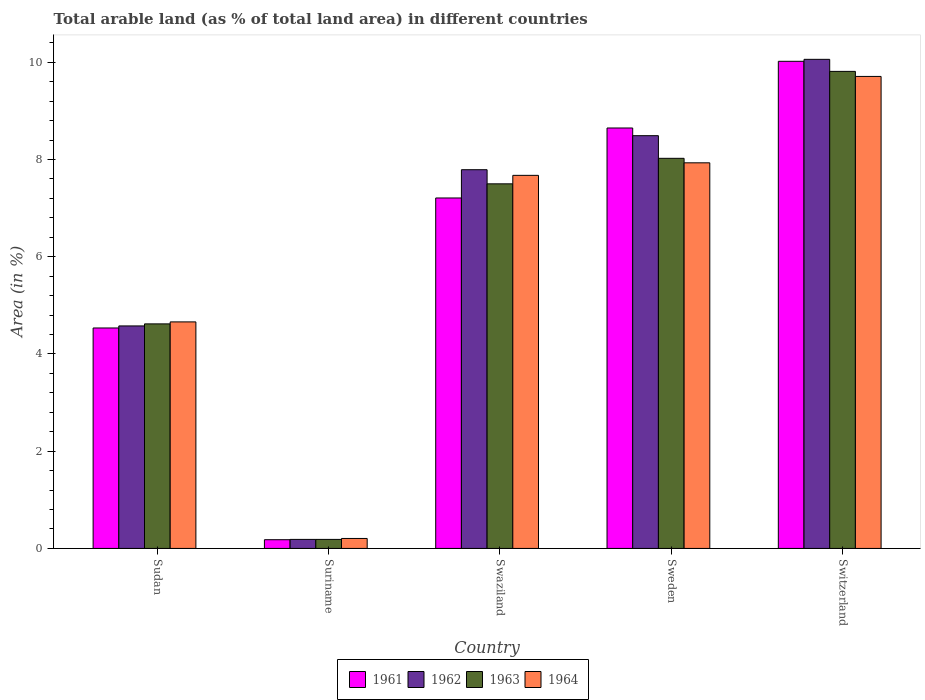How many different coloured bars are there?
Provide a short and direct response. 4. How many groups of bars are there?
Your response must be concise. 5. Are the number of bars per tick equal to the number of legend labels?
Your answer should be compact. Yes. Are the number of bars on each tick of the X-axis equal?
Keep it short and to the point. Yes. How many bars are there on the 1st tick from the left?
Ensure brevity in your answer.  4. How many bars are there on the 5th tick from the right?
Provide a succinct answer. 4. What is the label of the 5th group of bars from the left?
Offer a very short reply. Switzerland. In how many cases, is the number of bars for a given country not equal to the number of legend labels?
Keep it short and to the point. 0. What is the percentage of arable land in 1963 in Sudan?
Offer a terse response. 4.62. Across all countries, what is the maximum percentage of arable land in 1963?
Your response must be concise. 9.81. Across all countries, what is the minimum percentage of arable land in 1964?
Give a very brief answer. 0.21. In which country was the percentage of arable land in 1961 maximum?
Offer a very short reply. Switzerland. In which country was the percentage of arable land in 1964 minimum?
Your answer should be compact. Suriname. What is the total percentage of arable land in 1964 in the graph?
Make the answer very short. 30.18. What is the difference between the percentage of arable land in 1962 in Sudan and that in Suriname?
Offer a terse response. 4.39. What is the difference between the percentage of arable land in 1961 in Sudan and the percentage of arable land in 1963 in Swaziland?
Your response must be concise. -2.97. What is the average percentage of arable land in 1961 per country?
Provide a succinct answer. 6.12. What is the difference between the percentage of arable land of/in 1962 and percentage of arable land of/in 1963 in Sudan?
Provide a succinct answer. -0.04. In how many countries, is the percentage of arable land in 1963 greater than 1.2000000000000002 %?
Your answer should be compact. 4. What is the ratio of the percentage of arable land in 1961 in Sudan to that in Suriname?
Give a very brief answer. 25.27. What is the difference between the highest and the second highest percentage of arable land in 1964?
Provide a short and direct response. 2.04. What is the difference between the highest and the lowest percentage of arable land in 1963?
Provide a short and direct response. 9.63. Is it the case that in every country, the sum of the percentage of arable land in 1964 and percentage of arable land in 1962 is greater than the sum of percentage of arable land in 1961 and percentage of arable land in 1963?
Offer a terse response. No. What does the 3rd bar from the left in Sudan represents?
Offer a terse response. 1963. Is it the case that in every country, the sum of the percentage of arable land in 1961 and percentage of arable land in 1963 is greater than the percentage of arable land in 1962?
Your answer should be very brief. Yes. How many bars are there?
Keep it short and to the point. 20. How many countries are there in the graph?
Your answer should be very brief. 5. Does the graph contain grids?
Offer a terse response. No. How many legend labels are there?
Offer a terse response. 4. How are the legend labels stacked?
Offer a terse response. Horizontal. What is the title of the graph?
Make the answer very short. Total arable land (as % of total land area) in different countries. What is the label or title of the X-axis?
Offer a terse response. Country. What is the label or title of the Y-axis?
Provide a short and direct response. Area (in %). What is the Area (in %) of 1961 in Sudan?
Your answer should be compact. 4.53. What is the Area (in %) of 1962 in Sudan?
Keep it short and to the point. 4.58. What is the Area (in %) of 1963 in Sudan?
Provide a short and direct response. 4.62. What is the Area (in %) in 1964 in Sudan?
Ensure brevity in your answer.  4.66. What is the Area (in %) in 1961 in Suriname?
Your response must be concise. 0.18. What is the Area (in %) of 1962 in Suriname?
Give a very brief answer. 0.19. What is the Area (in %) of 1963 in Suriname?
Provide a succinct answer. 0.19. What is the Area (in %) of 1964 in Suriname?
Your answer should be compact. 0.21. What is the Area (in %) in 1961 in Swaziland?
Offer a very short reply. 7.21. What is the Area (in %) in 1962 in Swaziland?
Provide a short and direct response. 7.79. What is the Area (in %) of 1963 in Swaziland?
Your response must be concise. 7.5. What is the Area (in %) in 1964 in Swaziland?
Provide a succinct answer. 7.67. What is the Area (in %) of 1961 in Sweden?
Offer a very short reply. 8.65. What is the Area (in %) of 1962 in Sweden?
Give a very brief answer. 8.49. What is the Area (in %) of 1963 in Sweden?
Make the answer very short. 8.03. What is the Area (in %) of 1964 in Sweden?
Offer a very short reply. 7.93. What is the Area (in %) of 1961 in Switzerland?
Your answer should be compact. 10.02. What is the Area (in %) of 1962 in Switzerland?
Your answer should be very brief. 10.06. What is the Area (in %) of 1963 in Switzerland?
Your response must be concise. 9.81. What is the Area (in %) of 1964 in Switzerland?
Offer a very short reply. 9.71. Across all countries, what is the maximum Area (in %) of 1961?
Provide a short and direct response. 10.02. Across all countries, what is the maximum Area (in %) of 1962?
Ensure brevity in your answer.  10.06. Across all countries, what is the maximum Area (in %) of 1963?
Provide a succinct answer. 9.81. Across all countries, what is the maximum Area (in %) in 1964?
Your response must be concise. 9.71. Across all countries, what is the minimum Area (in %) of 1961?
Your answer should be compact. 0.18. Across all countries, what is the minimum Area (in %) in 1962?
Keep it short and to the point. 0.19. Across all countries, what is the minimum Area (in %) in 1963?
Make the answer very short. 0.19. Across all countries, what is the minimum Area (in %) of 1964?
Offer a very short reply. 0.21. What is the total Area (in %) of 1961 in the graph?
Your answer should be very brief. 30.59. What is the total Area (in %) in 1962 in the graph?
Make the answer very short. 31.11. What is the total Area (in %) of 1963 in the graph?
Offer a very short reply. 30.14. What is the total Area (in %) in 1964 in the graph?
Your answer should be very brief. 30.18. What is the difference between the Area (in %) in 1961 in Sudan and that in Suriname?
Your response must be concise. 4.36. What is the difference between the Area (in %) of 1962 in Sudan and that in Suriname?
Your response must be concise. 4.39. What is the difference between the Area (in %) of 1963 in Sudan and that in Suriname?
Provide a short and direct response. 4.43. What is the difference between the Area (in %) of 1964 in Sudan and that in Suriname?
Offer a very short reply. 4.45. What is the difference between the Area (in %) of 1961 in Sudan and that in Swaziland?
Make the answer very short. -2.67. What is the difference between the Area (in %) in 1962 in Sudan and that in Swaziland?
Your answer should be very brief. -3.21. What is the difference between the Area (in %) of 1963 in Sudan and that in Swaziland?
Your response must be concise. -2.88. What is the difference between the Area (in %) of 1964 in Sudan and that in Swaziland?
Offer a very short reply. -3.01. What is the difference between the Area (in %) of 1961 in Sudan and that in Sweden?
Your response must be concise. -4.11. What is the difference between the Area (in %) in 1962 in Sudan and that in Sweden?
Your answer should be very brief. -3.91. What is the difference between the Area (in %) in 1963 in Sudan and that in Sweden?
Your answer should be very brief. -3.41. What is the difference between the Area (in %) in 1964 in Sudan and that in Sweden?
Keep it short and to the point. -3.27. What is the difference between the Area (in %) of 1961 in Sudan and that in Switzerland?
Give a very brief answer. -5.49. What is the difference between the Area (in %) in 1962 in Sudan and that in Switzerland?
Give a very brief answer. -5.48. What is the difference between the Area (in %) of 1963 in Sudan and that in Switzerland?
Make the answer very short. -5.19. What is the difference between the Area (in %) in 1964 in Sudan and that in Switzerland?
Provide a short and direct response. -5.05. What is the difference between the Area (in %) of 1961 in Suriname and that in Swaziland?
Keep it short and to the point. -7.03. What is the difference between the Area (in %) of 1962 in Suriname and that in Swaziland?
Provide a short and direct response. -7.6. What is the difference between the Area (in %) in 1963 in Suriname and that in Swaziland?
Offer a terse response. -7.31. What is the difference between the Area (in %) in 1964 in Suriname and that in Swaziland?
Offer a terse response. -7.47. What is the difference between the Area (in %) of 1961 in Suriname and that in Sweden?
Offer a very short reply. -8.47. What is the difference between the Area (in %) in 1962 in Suriname and that in Sweden?
Keep it short and to the point. -8.3. What is the difference between the Area (in %) in 1963 in Suriname and that in Sweden?
Offer a very short reply. -7.84. What is the difference between the Area (in %) in 1964 in Suriname and that in Sweden?
Offer a terse response. -7.73. What is the difference between the Area (in %) of 1961 in Suriname and that in Switzerland?
Offer a terse response. -9.84. What is the difference between the Area (in %) of 1962 in Suriname and that in Switzerland?
Give a very brief answer. -9.88. What is the difference between the Area (in %) in 1963 in Suriname and that in Switzerland?
Your answer should be very brief. -9.63. What is the difference between the Area (in %) of 1964 in Suriname and that in Switzerland?
Your response must be concise. -9.5. What is the difference between the Area (in %) in 1961 in Swaziland and that in Sweden?
Your answer should be very brief. -1.44. What is the difference between the Area (in %) of 1962 in Swaziland and that in Sweden?
Your answer should be very brief. -0.7. What is the difference between the Area (in %) of 1963 in Swaziland and that in Sweden?
Give a very brief answer. -0.53. What is the difference between the Area (in %) in 1964 in Swaziland and that in Sweden?
Your response must be concise. -0.26. What is the difference between the Area (in %) of 1961 in Swaziland and that in Switzerland?
Ensure brevity in your answer.  -2.81. What is the difference between the Area (in %) in 1962 in Swaziland and that in Switzerland?
Your response must be concise. -2.27. What is the difference between the Area (in %) of 1963 in Swaziland and that in Switzerland?
Offer a very short reply. -2.31. What is the difference between the Area (in %) in 1964 in Swaziland and that in Switzerland?
Make the answer very short. -2.04. What is the difference between the Area (in %) of 1961 in Sweden and that in Switzerland?
Make the answer very short. -1.37. What is the difference between the Area (in %) of 1962 in Sweden and that in Switzerland?
Offer a very short reply. -1.57. What is the difference between the Area (in %) in 1963 in Sweden and that in Switzerland?
Make the answer very short. -1.79. What is the difference between the Area (in %) in 1964 in Sweden and that in Switzerland?
Make the answer very short. -1.78. What is the difference between the Area (in %) in 1961 in Sudan and the Area (in %) in 1962 in Suriname?
Provide a succinct answer. 4.35. What is the difference between the Area (in %) in 1961 in Sudan and the Area (in %) in 1963 in Suriname?
Offer a very short reply. 4.35. What is the difference between the Area (in %) of 1961 in Sudan and the Area (in %) of 1964 in Suriname?
Provide a succinct answer. 4.33. What is the difference between the Area (in %) in 1962 in Sudan and the Area (in %) in 1963 in Suriname?
Keep it short and to the point. 4.39. What is the difference between the Area (in %) in 1962 in Sudan and the Area (in %) in 1964 in Suriname?
Your answer should be very brief. 4.37. What is the difference between the Area (in %) in 1963 in Sudan and the Area (in %) in 1964 in Suriname?
Ensure brevity in your answer.  4.41. What is the difference between the Area (in %) in 1961 in Sudan and the Area (in %) in 1962 in Swaziland?
Give a very brief answer. -3.26. What is the difference between the Area (in %) of 1961 in Sudan and the Area (in %) of 1963 in Swaziland?
Give a very brief answer. -2.97. What is the difference between the Area (in %) of 1961 in Sudan and the Area (in %) of 1964 in Swaziland?
Make the answer very short. -3.14. What is the difference between the Area (in %) of 1962 in Sudan and the Area (in %) of 1963 in Swaziland?
Your answer should be compact. -2.92. What is the difference between the Area (in %) of 1962 in Sudan and the Area (in %) of 1964 in Swaziland?
Keep it short and to the point. -3.1. What is the difference between the Area (in %) of 1963 in Sudan and the Area (in %) of 1964 in Swaziland?
Your answer should be very brief. -3.06. What is the difference between the Area (in %) of 1961 in Sudan and the Area (in %) of 1962 in Sweden?
Keep it short and to the point. -3.96. What is the difference between the Area (in %) of 1961 in Sudan and the Area (in %) of 1963 in Sweden?
Keep it short and to the point. -3.49. What is the difference between the Area (in %) of 1961 in Sudan and the Area (in %) of 1964 in Sweden?
Give a very brief answer. -3.4. What is the difference between the Area (in %) in 1962 in Sudan and the Area (in %) in 1963 in Sweden?
Make the answer very short. -3.45. What is the difference between the Area (in %) in 1962 in Sudan and the Area (in %) in 1964 in Sweden?
Make the answer very short. -3.36. What is the difference between the Area (in %) of 1963 in Sudan and the Area (in %) of 1964 in Sweden?
Ensure brevity in your answer.  -3.31. What is the difference between the Area (in %) in 1961 in Sudan and the Area (in %) in 1962 in Switzerland?
Your response must be concise. -5.53. What is the difference between the Area (in %) of 1961 in Sudan and the Area (in %) of 1963 in Switzerland?
Provide a succinct answer. -5.28. What is the difference between the Area (in %) of 1961 in Sudan and the Area (in %) of 1964 in Switzerland?
Your response must be concise. -5.17. What is the difference between the Area (in %) of 1962 in Sudan and the Area (in %) of 1963 in Switzerland?
Your response must be concise. -5.24. What is the difference between the Area (in %) in 1962 in Sudan and the Area (in %) in 1964 in Switzerland?
Make the answer very short. -5.13. What is the difference between the Area (in %) in 1963 in Sudan and the Area (in %) in 1964 in Switzerland?
Your answer should be very brief. -5.09. What is the difference between the Area (in %) of 1961 in Suriname and the Area (in %) of 1962 in Swaziland?
Provide a succinct answer. -7.61. What is the difference between the Area (in %) of 1961 in Suriname and the Area (in %) of 1963 in Swaziland?
Keep it short and to the point. -7.32. What is the difference between the Area (in %) of 1961 in Suriname and the Area (in %) of 1964 in Swaziland?
Provide a succinct answer. -7.49. What is the difference between the Area (in %) in 1962 in Suriname and the Area (in %) in 1963 in Swaziland?
Offer a terse response. -7.31. What is the difference between the Area (in %) of 1962 in Suriname and the Area (in %) of 1964 in Swaziland?
Give a very brief answer. -7.49. What is the difference between the Area (in %) of 1963 in Suriname and the Area (in %) of 1964 in Swaziland?
Ensure brevity in your answer.  -7.49. What is the difference between the Area (in %) of 1961 in Suriname and the Area (in %) of 1962 in Sweden?
Offer a very short reply. -8.31. What is the difference between the Area (in %) of 1961 in Suriname and the Area (in %) of 1963 in Sweden?
Give a very brief answer. -7.85. What is the difference between the Area (in %) of 1961 in Suriname and the Area (in %) of 1964 in Sweden?
Offer a terse response. -7.75. What is the difference between the Area (in %) of 1962 in Suriname and the Area (in %) of 1963 in Sweden?
Your answer should be very brief. -7.84. What is the difference between the Area (in %) of 1962 in Suriname and the Area (in %) of 1964 in Sweden?
Your answer should be compact. -7.75. What is the difference between the Area (in %) in 1963 in Suriname and the Area (in %) in 1964 in Sweden?
Give a very brief answer. -7.75. What is the difference between the Area (in %) in 1961 in Suriname and the Area (in %) in 1962 in Switzerland?
Your response must be concise. -9.88. What is the difference between the Area (in %) of 1961 in Suriname and the Area (in %) of 1963 in Switzerland?
Your answer should be very brief. -9.63. What is the difference between the Area (in %) in 1961 in Suriname and the Area (in %) in 1964 in Switzerland?
Keep it short and to the point. -9.53. What is the difference between the Area (in %) of 1962 in Suriname and the Area (in %) of 1963 in Switzerland?
Give a very brief answer. -9.63. What is the difference between the Area (in %) in 1962 in Suriname and the Area (in %) in 1964 in Switzerland?
Ensure brevity in your answer.  -9.52. What is the difference between the Area (in %) of 1963 in Suriname and the Area (in %) of 1964 in Switzerland?
Provide a succinct answer. -9.52. What is the difference between the Area (in %) of 1961 in Swaziland and the Area (in %) of 1962 in Sweden?
Offer a very short reply. -1.28. What is the difference between the Area (in %) of 1961 in Swaziland and the Area (in %) of 1963 in Sweden?
Make the answer very short. -0.82. What is the difference between the Area (in %) of 1961 in Swaziland and the Area (in %) of 1964 in Sweden?
Your response must be concise. -0.72. What is the difference between the Area (in %) of 1962 in Swaziland and the Area (in %) of 1963 in Sweden?
Your answer should be compact. -0.23. What is the difference between the Area (in %) in 1962 in Swaziland and the Area (in %) in 1964 in Sweden?
Make the answer very short. -0.14. What is the difference between the Area (in %) of 1963 in Swaziland and the Area (in %) of 1964 in Sweden?
Give a very brief answer. -0.43. What is the difference between the Area (in %) in 1961 in Swaziland and the Area (in %) in 1962 in Switzerland?
Make the answer very short. -2.85. What is the difference between the Area (in %) of 1961 in Swaziland and the Area (in %) of 1963 in Switzerland?
Keep it short and to the point. -2.6. What is the difference between the Area (in %) of 1961 in Swaziland and the Area (in %) of 1964 in Switzerland?
Ensure brevity in your answer.  -2.5. What is the difference between the Area (in %) in 1962 in Swaziland and the Area (in %) in 1963 in Switzerland?
Keep it short and to the point. -2.02. What is the difference between the Area (in %) in 1962 in Swaziland and the Area (in %) in 1964 in Switzerland?
Your response must be concise. -1.92. What is the difference between the Area (in %) of 1963 in Swaziland and the Area (in %) of 1964 in Switzerland?
Provide a short and direct response. -2.21. What is the difference between the Area (in %) of 1961 in Sweden and the Area (in %) of 1962 in Switzerland?
Keep it short and to the point. -1.41. What is the difference between the Area (in %) in 1961 in Sweden and the Area (in %) in 1963 in Switzerland?
Your answer should be compact. -1.16. What is the difference between the Area (in %) in 1961 in Sweden and the Area (in %) in 1964 in Switzerland?
Ensure brevity in your answer.  -1.06. What is the difference between the Area (in %) of 1962 in Sweden and the Area (in %) of 1963 in Switzerland?
Make the answer very short. -1.32. What is the difference between the Area (in %) of 1962 in Sweden and the Area (in %) of 1964 in Switzerland?
Give a very brief answer. -1.22. What is the difference between the Area (in %) of 1963 in Sweden and the Area (in %) of 1964 in Switzerland?
Provide a short and direct response. -1.68. What is the average Area (in %) of 1961 per country?
Provide a succinct answer. 6.12. What is the average Area (in %) of 1962 per country?
Your answer should be very brief. 6.22. What is the average Area (in %) in 1963 per country?
Your response must be concise. 6.03. What is the average Area (in %) of 1964 per country?
Provide a short and direct response. 6.04. What is the difference between the Area (in %) in 1961 and Area (in %) in 1962 in Sudan?
Offer a terse response. -0.04. What is the difference between the Area (in %) in 1961 and Area (in %) in 1963 in Sudan?
Provide a succinct answer. -0.08. What is the difference between the Area (in %) in 1961 and Area (in %) in 1964 in Sudan?
Provide a short and direct response. -0.12. What is the difference between the Area (in %) of 1962 and Area (in %) of 1963 in Sudan?
Provide a short and direct response. -0.04. What is the difference between the Area (in %) in 1962 and Area (in %) in 1964 in Sudan?
Ensure brevity in your answer.  -0.08. What is the difference between the Area (in %) of 1963 and Area (in %) of 1964 in Sudan?
Make the answer very short. -0.04. What is the difference between the Area (in %) of 1961 and Area (in %) of 1962 in Suriname?
Your response must be concise. -0.01. What is the difference between the Area (in %) in 1961 and Area (in %) in 1963 in Suriname?
Your answer should be compact. -0.01. What is the difference between the Area (in %) of 1961 and Area (in %) of 1964 in Suriname?
Offer a very short reply. -0.03. What is the difference between the Area (in %) of 1962 and Area (in %) of 1964 in Suriname?
Provide a succinct answer. -0.02. What is the difference between the Area (in %) of 1963 and Area (in %) of 1964 in Suriname?
Your answer should be compact. -0.02. What is the difference between the Area (in %) in 1961 and Area (in %) in 1962 in Swaziland?
Your response must be concise. -0.58. What is the difference between the Area (in %) in 1961 and Area (in %) in 1963 in Swaziland?
Make the answer very short. -0.29. What is the difference between the Area (in %) of 1961 and Area (in %) of 1964 in Swaziland?
Offer a very short reply. -0.47. What is the difference between the Area (in %) of 1962 and Area (in %) of 1963 in Swaziland?
Provide a succinct answer. 0.29. What is the difference between the Area (in %) of 1962 and Area (in %) of 1964 in Swaziland?
Give a very brief answer. 0.12. What is the difference between the Area (in %) of 1963 and Area (in %) of 1964 in Swaziland?
Your answer should be very brief. -0.17. What is the difference between the Area (in %) of 1961 and Area (in %) of 1962 in Sweden?
Make the answer very short. 0.16. What is the difference between the Area (in %) in 1961 and Area (in %) in 1963 in Sweden?
Keep it short and to the point. 0.62. What is the difference between the Area (in %) in 1961 and Area (in %) in 1964 in Sweden?
Provide a short and direct response. 0.72. What is the difference between the Area (in %) in 1962 and Area (in %) in 1963 in Sweden?
Your response must be concise. 0.47. What is the difference between the Area (in %) in 1962 and Area (in %) in 1964 in Sweden?
Ensure brevity in your answer.  0.56. What is the difference between the Area (in %) of 1963 and Area (in %) of 1964 in Sweden?
Ensure brevity in your answer.  0.09. What is the difference between the Area (in %) in 1961 and Area (in %) in 1962 in Switzerland?
Your answer should be very brief. -0.04. What is the difference between the Area (in %) of 1961 and Area (in %) of 1963 in Switzerland?
Provide a short and direct response. 0.21. What is the difference between the Area (in %) in 1961 and Area (in %) in 1964 in Switzerland?
Provide a succinct answer. 0.31. What is the difference between the Area (in %) of 1962 and Area (in %) of 1963 in Switzerland?
Your answer should be very brief. 0.25. What is the difference between the Area (in %) in 1962 and Area (in %) in 1964 in Switzerland?
Keep it short and to the point. 0.35. What is the difference between the Area (in %) of 1963 and Area (in %) of 1964 in Switzerland?
Give a very brief answer. 0.1. What is the ratio of the Area (in %) in 1961 in Sudan to that in Suriname?
Give a very brief answer. 25.27. What is the ratio of the Area (in %) in 1962 in Sudan to that in Suriname?
Make the answer very short. 24.62. What is the ratio of the Area (in %) of 1963 in Sudan to that in Suriname?
Make the answer very short. 24.85. What is the ratio of the Area (in %) of 1964 in Sudan to that in Suriname?
Make the answer very short. 22.72. What is the ratio of the Area (in %) of 1961 in Sudan to that in Swaziland?
Offer a very short reply. 0.63. What is the ratio of the Area (in %) of 1962 in Sudan to that in Swaziland?
Provide a short and direct response. 0.59. What is the ratio of the Area (in %) of 1963 in Sudan to that in Swaziland?
Provide a succinct answer. 0.62. What is the ratio of the Area (in %) in 1964 in Sudan to that in Swaziland?
Offer a terse response. 0.61. What is the ratio of the Area (in %) in 1961 in Sudan to that in Sweden?
Your response must be concise. 0.52. What is the ratio of the Area (in %) of 1962 in Sudan to that in Sweden?
Ensure brevity in your answer.  0.54. What is the ratio of the Area (in %) of 1963 in Sudan to that in Sweden?
Offer a terse response. 0.58. What is the ratio of the Area (in %) of 1964 in Sudan to that in Sweden?
Provide a short and direct response. 0.59. What is the ratio of the Area (in %) of 1961 in Sudan to that in Switzerland?
Make the answer very short. 0.45. What is the ratio of the Area (in %) of 1962 in Sudan to that in Switzerland?
Offer a terse response. 0.45. What is the ratio of the Area (in %) in 1963 in Sudan to that in Switzerland?
Your answer should be compact. 0.47. What is the ratio of the Area (in %) in 1964 in Sudan to that in Switzerland?
Offer a very short reply. 0.48. What is the ratio of the Area (in %) of 1961 in Suriname to that in Swaziland?
Your answer should be compact. 0.02. What is the ratio of the Area (in %) of 1962 in Suriname to that in Swaziland?
Make the answer very short. 0.02. What is the ratio of the Area (in %) in 1963 in Suriname to that in Swaziland?
Give a very brief answer. 0.02. What is the ratio of the Area (in %) in 1964 in Suriname to that in Swaziland?
Your response must be concise. 0.03. What is the ratio of the Area (in %) of 1961 in Suriname to that in Sweden?
Ensure brevity in your answer.  0.02. What is the ratio of the Area (in %) of 1962 in Suriname to that in Sweden?
Ensure brevity in your answer.  0.02. What is the ratio of the Area (in %) of 1963 in Suriname to that in Sweden?
Your answer should be compact. 0.02. What is the ratio of the Area (in %) of 1964 in Suriname to that in Sweden?
Keep it short and to the point. 0.03. What is the ratio of the Area (in %) in 1961 in Suriname to that in Switzerland?
Your answer should be very brief. 0.02. What is the ratio of the Area (in %) in 1962 in Suriname to that in Switzerland?
Provide a short and direct response. 0.02. What is the ratio of the Area (in %) of 1963 in Suriname to that in Switzerland?
Your answer should be compact. 0.02. What is the ratio of the Area (in %) of 1964 in Suriname to that in Switzerland?
Provide a succinct answer. 0.02. What is the ratio of the Area (in %) of 1961 in Swaziland to that in Sweden?
Your response must be concise. 0.83. What is the ratio of the Area (in %) of 1962 in Swaziland to that in Sweden?
Give a very brief answer. 0.92. What is the ratio of the Area (in %) in 1963 in Swaziland to that in Sweden?
Offer a very short reply. 0.93. What is the ratio of the Area (in %) in 1964 in Swaziland to that in Sweden?
Make the answer very short. 0.97. What is the ratio of the Area (in %) of 1961 in Swaziland to that in Switzerland?
Provide a short and direct response. 0.72. What is the ratio of the Area (in %) in 1962 in Swaziland to that in Switzerland?
Your response must be concise. 0.77. What is the ratio of the Area (in %) in 1963 in Swaziland to that in Switzerland?
Keep it short and to the point. 0.76. What is the ratio of the Area (in %) of 1964 in Swaziland to that in Switzerland?
Ensure brevity in your answer.  0.79. What is the ratio of the Area (in %) of 1961 in Sweden to that in Switzerland?
Ensure brevity in your answer.  0.86. What is the ratio of the Area (in %) of 1962 in Sweden to that in Switzerland?
Give a very brief answer. 0.84. What is the ratio of the Area (in %) in 1963 in Sweden to that in Switzerland?
Your response must be concise. 0.82. What is the ratio of the Area (in %) in 1964 in Sweden to that in Switzerland?
Your answer should be compact. 0.82. What is the difference between the highest and the second highest Area (in %) in 1961?
Your answer should be very brief. 1.37. What is the difference between the highest and the second highest Area (in %) of 1962?
Give a very brief answer. 1.57. What is the difference between the highest and the second highest Area (in %) of 1963?
Offer a very short reply. 1.79. What is the difference between the highest and the second highest Area (in %) of 1964?
Offer a terse response. 1.78. What is the difference between the highest and the lowest Area (in %) in 1961?
Provide a succinct answer. 9.84. What is the difference between the highest and the lowest Area (in %) in 1962?
Provide a succinct answer. 9.88. What is the difference between the highest and the lowest Area (in %) of 1963?
Give a very brief answer. 9.63. What is the difference between the highest and the lowest Area (in %) in 1964?
Give a very brief answer. 9.5. 